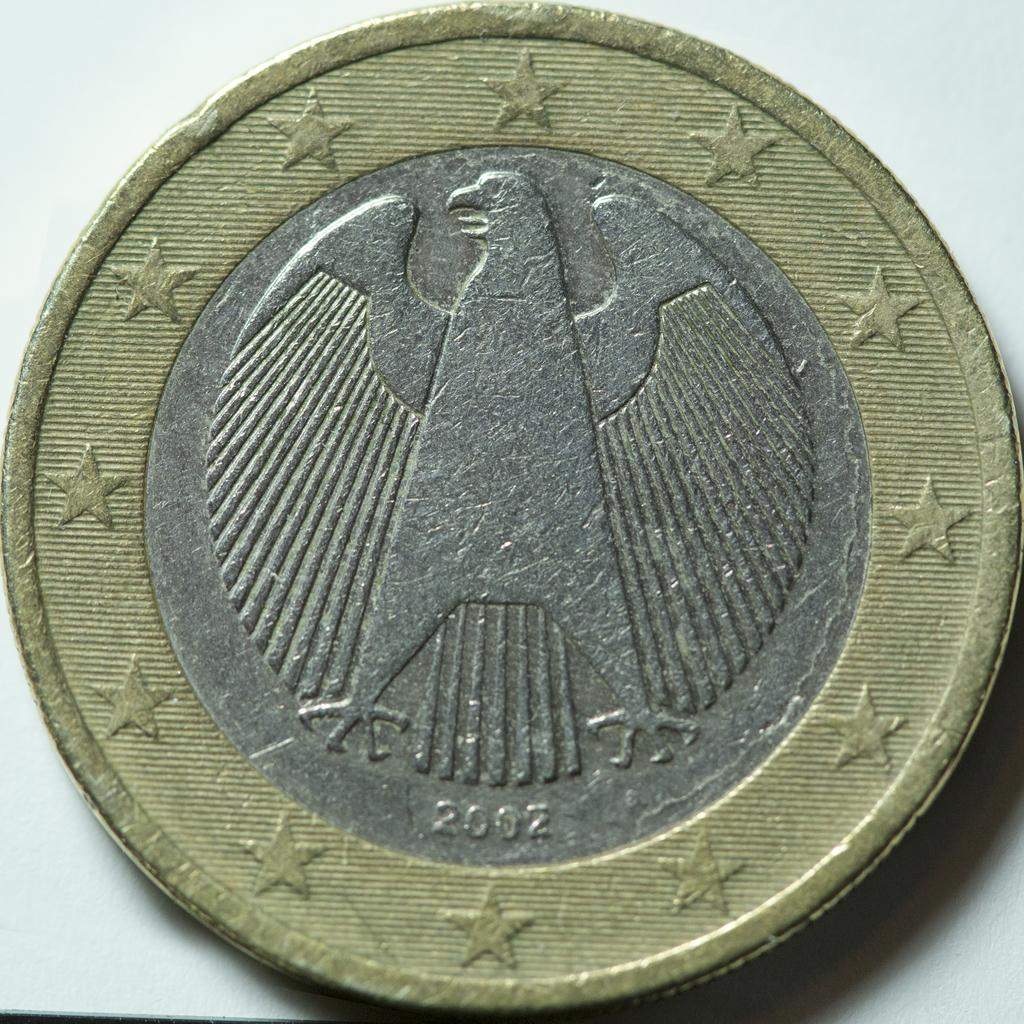<image>
Write a terse but informative summary of the picture. A 2002 coin is two colored and features an eagle. 